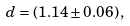Convert formula to latex. <formula><loc_0><loc_0><loc_500><loc_500>d = ( 1 . 1 4 \pm 0 . 0 6 ) \, ,</formula> 